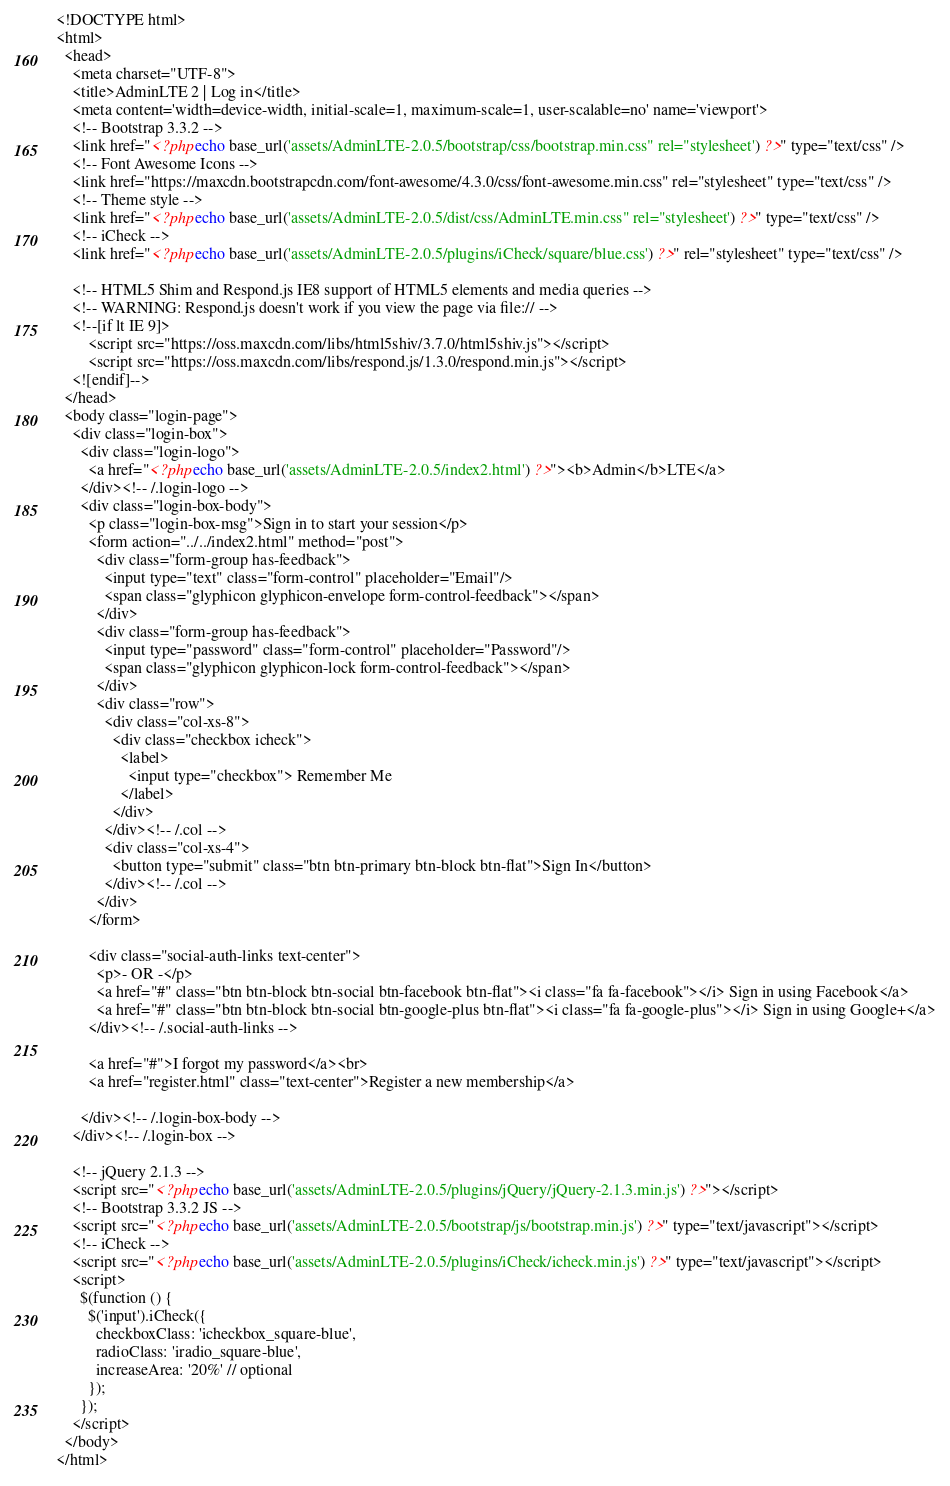<code> <loc_0><loc_0><loc_500><loc_500><_PHP_><!DOCTYPE html>
<html>
  <head>
    <meta charset="UTF-8">
    <title>AdminLTE 2 | Log in</title>
    <meta content='width=device-width, initial-scale=1, maximum-scale=1, user-scalable=no' name='viewport'>
    <!-- Bootstrap 3.3.2 -->
    <link href="<?php echo base_url('assets/AdminLTE-2.0.5/bootstrap/css/bootstrap.min.css" rel="stylesheet') ?>" type="text/css" />
    <!-- Font Awesome Icons -->
    <link href="https://maxcdn.bootstrapcdn.com/font-awesome/4.3.0/css/font-awesome.min.css" rel="stylesheet" type="text/css" />
    <!-- Theme style -->
    <link href="<?php echo base_url('assets/AdminLTE-2.0.5/dist/css/AdminLTE.min.css" rel="stylesheet') ?>" type="text/css" />
    <!-- iCheck -->
    <link href="<?php echo base_url('assets/AdminLTE-2.0.5/plugins/iCheck/square/blue.css') ?>" rel="stylesheet" type="text/css" />

    <!-- HTML5 Shim and Respond.js IE8 support of HTML5 elements and media queries -->
    <!-- WARNING: Respond.js doesn't work if you view the page via file:// -->
    <!--[if lt IE 9]>
        <script src="https://oss.maxcdn.com/libs/html5shiv/3.7.0/html5shiv.js"></script>
        <script src="https://oss.maxcdn.com/libs/respond.js/1.3.0/respond.min.js"></script>
    <![endif]-->
  </head>
  <body class="login-page">
    <div class="login-box">
      <div class="login-logo">
        <a href="<?php echo base_url('assets/AdminLTE-2.0.5/index2.html') ?>"><b>Admin</b>LTE</a>
      </div><!-- /.login-logo -->
      <div class="login-box-body">
        <p class="login-box-msg">Sign in to start your session</p>
        <form action="../../index2.html" method="post">
          <div class="form-group has-feedback">
            <input type="text" class="form-control" placeholder="Email"/>
            <span class="glyphicon glyphicon-envelope form-control-feedback"></span>
          </div>
          <div class="form-group has-feedback">
            <input type="password" class="form-control" placeholder="Password"/>
            <span class="glyphicon glyphicon-lock form-control-feedback"></span>
          </div>
          <div class="row">
            <div class="col-xs-8">    
              <div class="checkbox icheck">
                <label>
                  <input type="checkbox"> Remember Me
                </label>
              </div>                        
            </div><!-- /.col -->
            <div class="col-xs-4">
              <button type="submit" class="btn btn-primary btn-block btn-flat">Sign In</button>
            </div><!-- /.col -->
          </div>
        </form>

        <div class="social-auth-links text-center">
          <p>- OR -</p>
          <a href="#" class="btn btn-block btn-social btn-facebook btn-flat"><i class="fa fa-facebook"></i> Sign in using Facebook</a>
          <a href="#" class="btn btn-block btn-social btn-google-plus btn-flat"><i class="fa fa-google-plus"></i> Sign in using Google+</a>
        </div><!-- /.social-auth-links -->

        <a href="#">I forgot my password</a><br>
        <a href="register.html" class="text-center">Register a new membership</a>

      </div><!-- /.login-box-body -->
    </div><!-- /.login-box -->

    <!-- jQuery 2.1.3 -->
    <script src="<?php echo base_url('assets/AdminLTE-2.0.5/plugins/jQuery/jQuery-2.1.3.min.js') ?>"></script>
    <!-- Bootstrap 3.3.2 JS -->
    <script src="<?php echo base_url('assets/AdminLTE-2.0.5/bootstrap/js/bootstrap.min.js') ?>" type="text/javascript"></script>
    <!-- iCheck -->
    <script src="<?php echo base_url('assets/AdminLTE-2.0.5/plugins/iCheck/icheck.min.js') ?>" type="text/javascript"></script>
    <script>
      $(function () {
        $('input').iCheck({
          checkboxClass: 'icheckbox_square-blue',
          radioClass: 'iradio_square-blue',
          increaseArea: '20%' // optional
        });
      });
    </script>
  </body>
</html></code> 